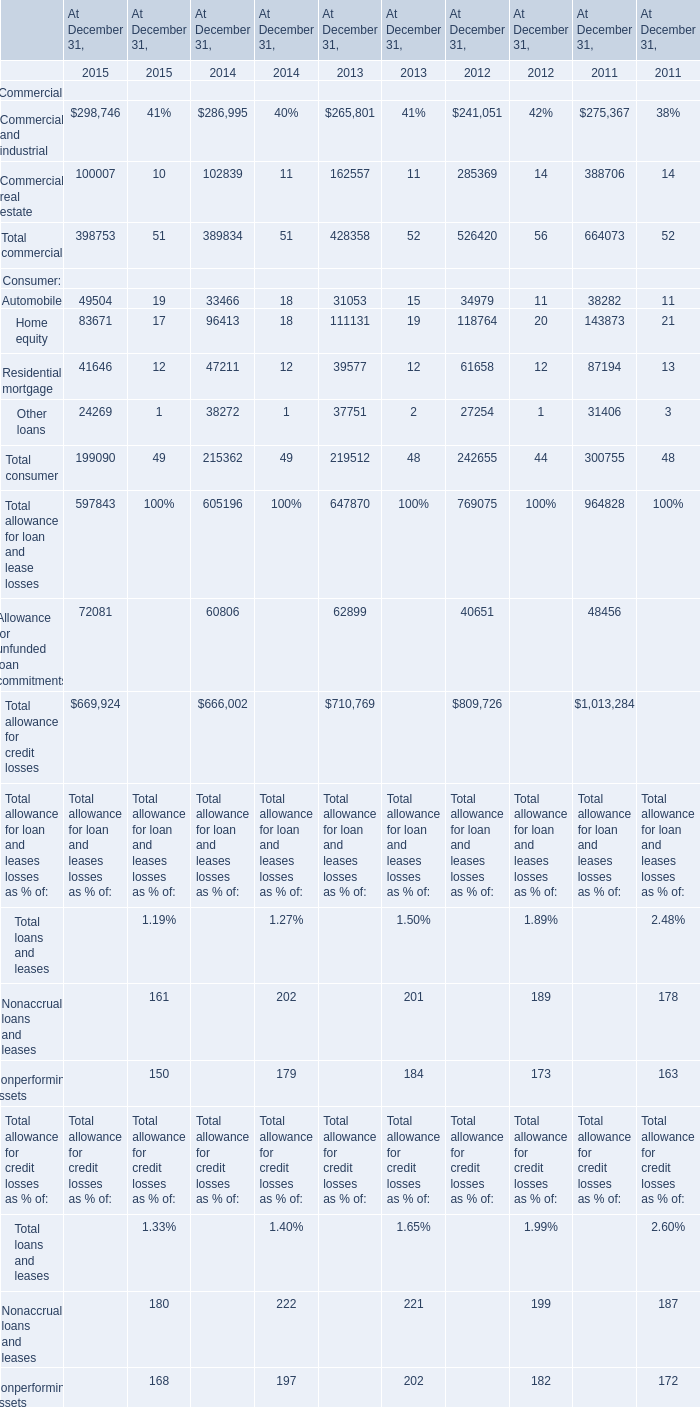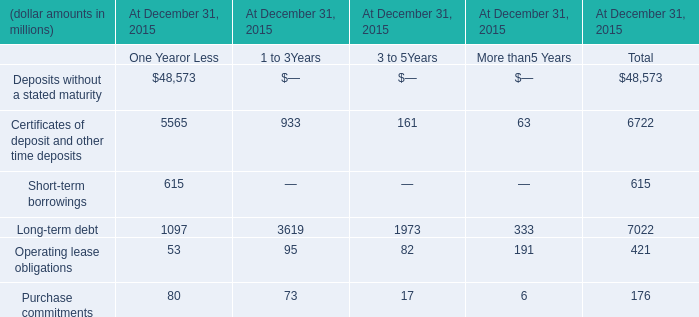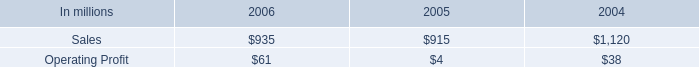what was the average cash provided by the continuing operations from 2004 to 2006 in billions 
Computations: (((1 + 1.2) / 1.7) / 3)
Answer: 0.43137. 